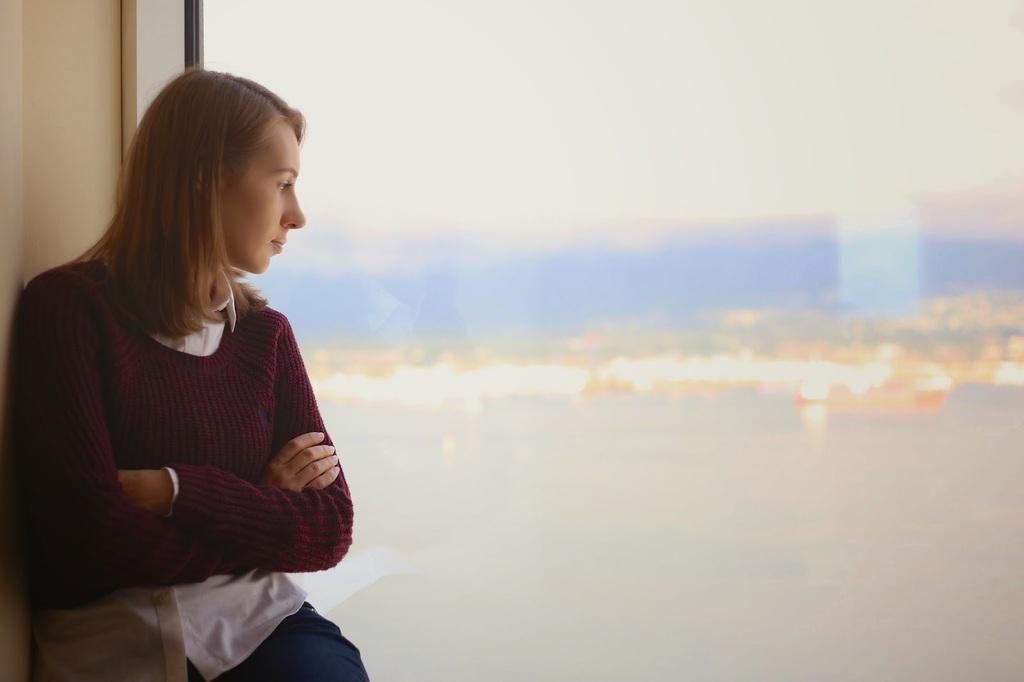Please provide a concise description of this image. Here in this picture we can see a woman standing over a place and we can see she is wearing a sweater on her and she is seeing through the glass window present and outside the window we can see water present all over there and we can also see other things in blurry manner. 